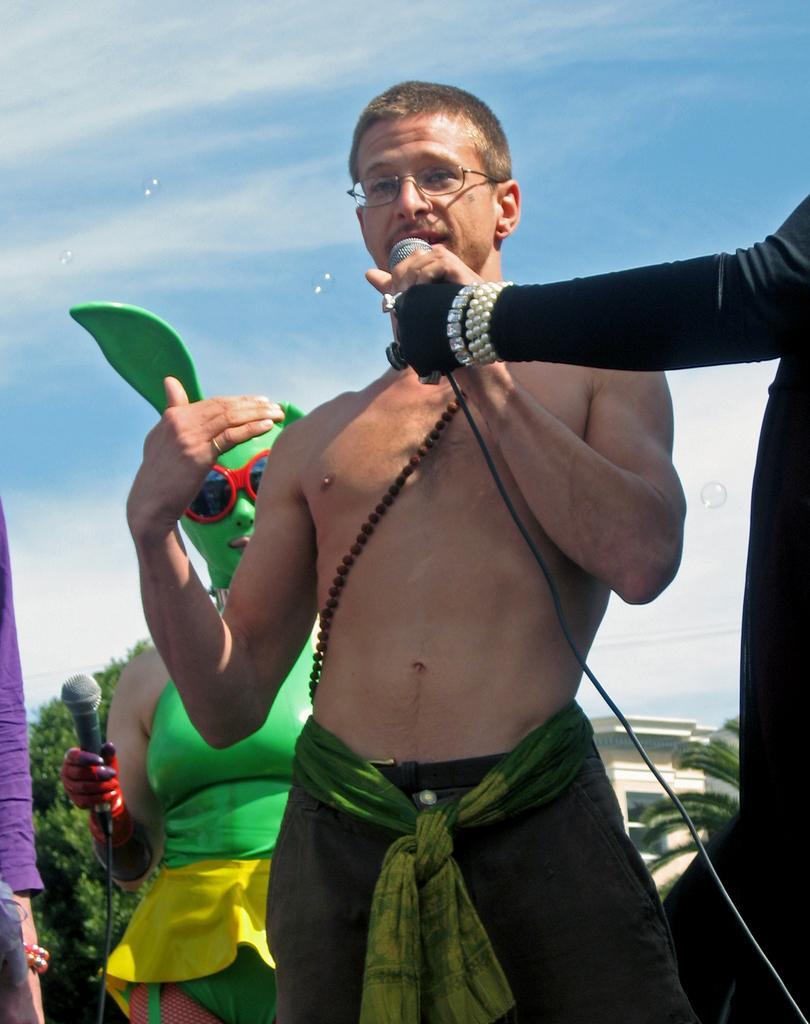How would you summarize this image in a sentence or two? In this image we can see one man standing, holding a microphone and talking in the middle of the image. There are two persons truncated on the left and right side of the image. One man holding a microphone on the left side of the image, one woman in costume standing and holding a microphone. There are some trees, one object on the left side of the image, one building in the background, some bubbles in the background and there is the cloudy sky in the background. 